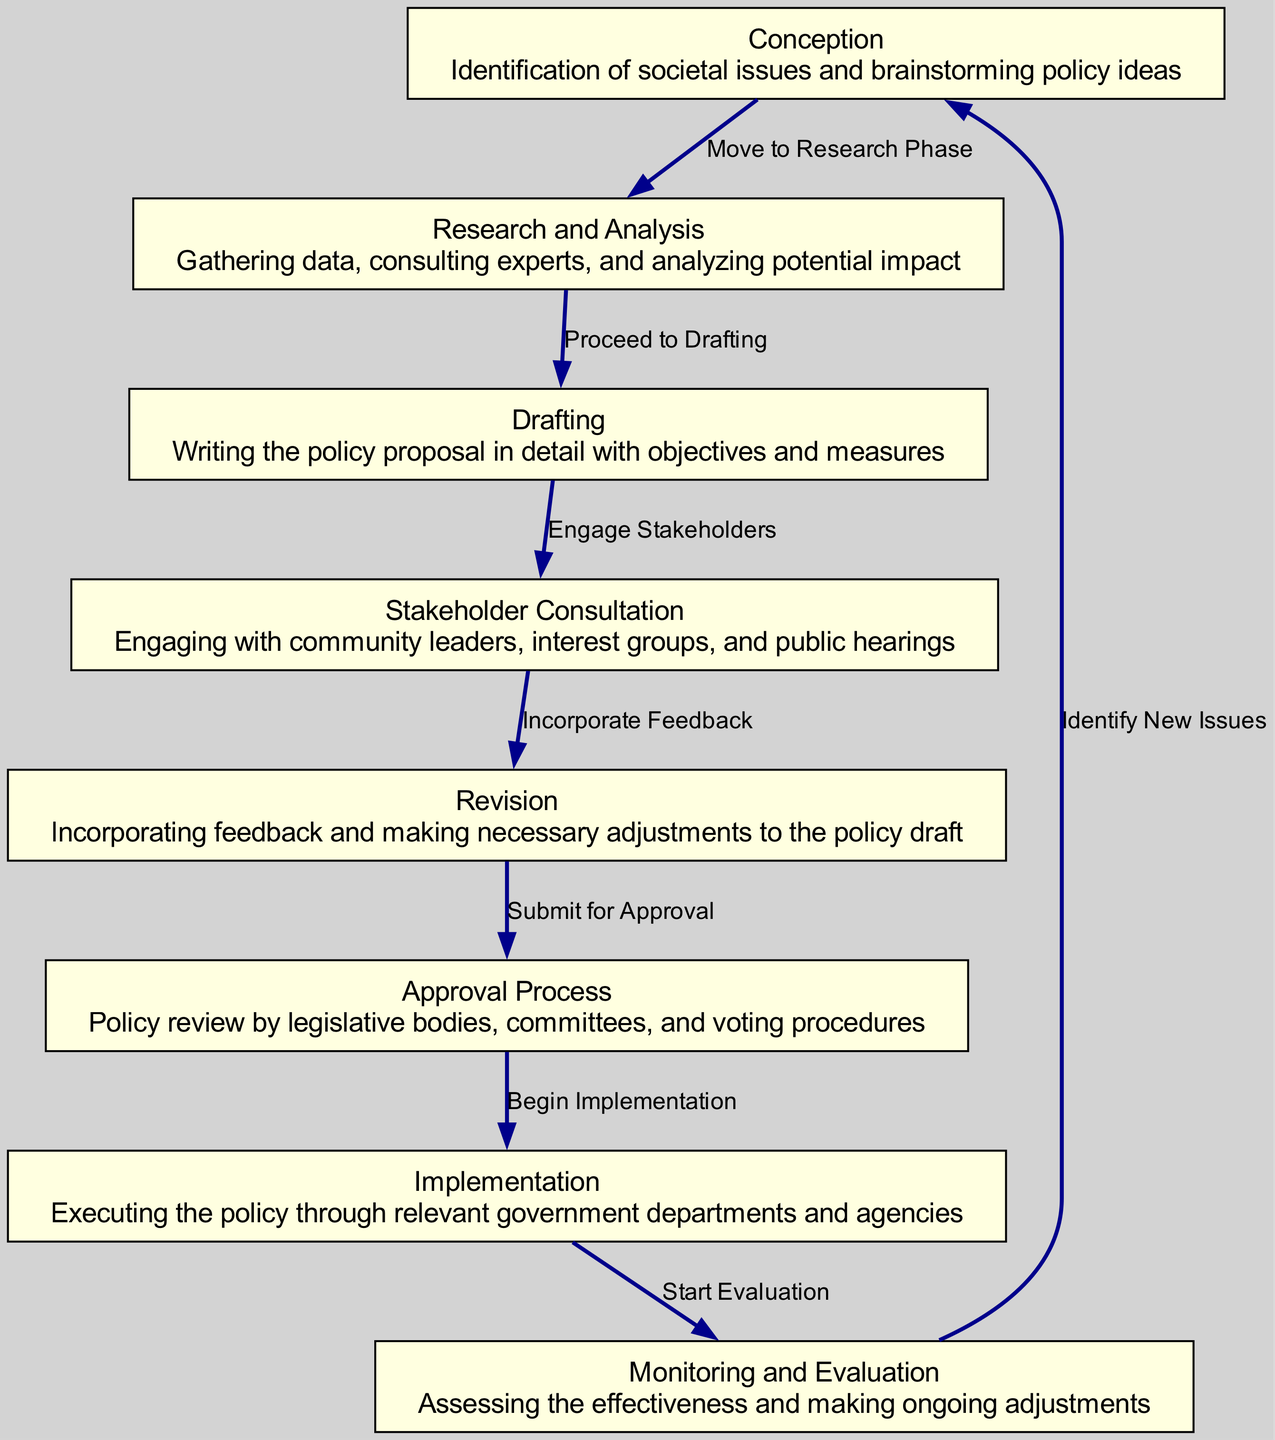What is the first step in the policy journey? The first step is "Conception," which involves identifying societal issues and brainstorming policy ideas.
Answer: Conception How many nodes are present in the diagram? The diagram contains a total of eight nodes, representing the key steps of the policy journey.
Answer: Eight What is the label for the node that comes after "Research and Analysis"? The node that comes after "Research and Analysis" is labeled "Drafting."
Answer: Drafting What step follows "Stakeholder Consultation"? The step that follows "Stakeholder Consultation" is "Revision." This indicates that after consulting stakeholders, feedback is incorporated.
Answer: Revision How many edges are there in the diagram? There are a total of seven edges, showing the transitions from one step to another in the policy process.
Answer: Seven What is the description of the "Implementation" node? The description states that "Implementation" involves executing the policy through relevant government departments and agencies.
Answer: Executing the policy What transition occurs after the "Approval Process"? After the "Approval Process," the transition to "Implementation" occurs, which signifies the start of executing the approved policy.
Answer: Begin Implementation What is the final node in the policy flow? The final node in the policy flow is "Monitoring and Evaluation," which assesses the effectiveness of the policy and makes adjustments.
Answer: Monitoring and Evaluation What does "Monitoring and Evaluation" lead to? "Monitoring and Evaluation" leads back to "Conception," indicating a continuous loop of identifying new issues based on evaluated policies.
Answer: Identify New Issues 